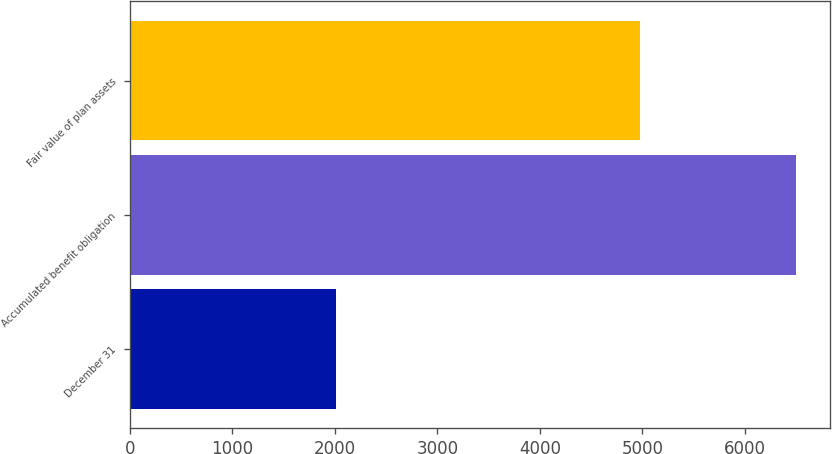<chart> <loc_0><loc_0><loc_500><loc_500><bar_chart><fcel>December 31<fcel>Accumulated benefit obligation<fcel>Fair value of plan assets<nl><fcel>2010<fcel>6503<fcel>4981<nl></chart> 